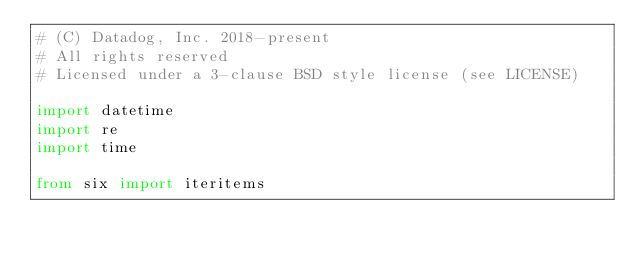Convert code to text. <code><loc_0><loc_0><loc_500><loc_500><_Python_># (C) Datadog, Inc. 2018-present
# All rights reserved
# Licensed under a 3-clause BSD style license (see LICENSE)

import datetime
import re
import time

from six import iteritems
</code> 